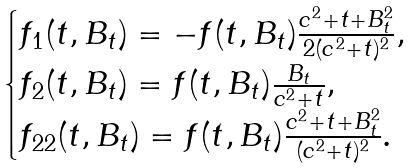<formula> <loc_0><loc_0><loc_500><loc_500>\begin{cases} f _ { 1 } ( t , B _ { t } ) = - f ( t , B _ { t } ) \frac { c ^ { 2 } + t + B _ { t } ^ { 2 } } { 2 ( c ^ { 2 } + t ) ^ { 2 } } , \\ f _ { 2 } ( t , B _ { t } ) = f ( t , B _ { t } ) \frac { B _ { t } } { c ^ { 2 } + t } , \\ f _ { 2 2 } ( t , B _ { t } ) = f ( t , B _ { t } ) \frac { c ^ { 2 } + t + B _ { t } ^ { 2 } } { ( c ^ { 2 } + t ) ^ { 2 } } . \end{cases}</formula> 